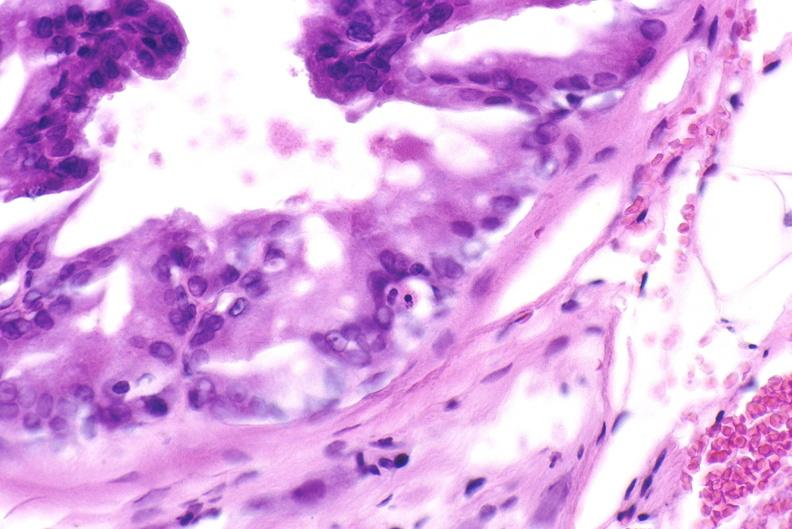when does this image show apoptosis in prostate?
Answer the question using a single word or phrase. After orchiectomy 